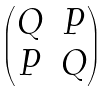Convert formula to latex. <formula><loc_0><loc_0><loc_500><loc_500>\begin{pmatrix} Q & P \\ P & Q \end{pmatrix}</formula> 